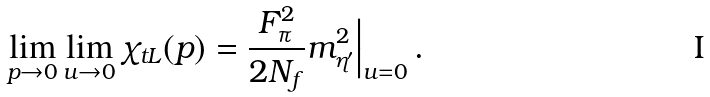Convert formula to latex. <formula><loc_0><loc_0><loc_500><loc_500>\lim _ { p \rightarrow 0 } \lim _ { u \rightarrow 0 } \chi _ { t L } ( p ) = \frac { F _ { \pi } ^ { 2 } } { 2 N _ { f } } m _ { \eta ^ { \prime } } ^ { 2 } \Big { | } _ { u = 0 } \, .</formula> 